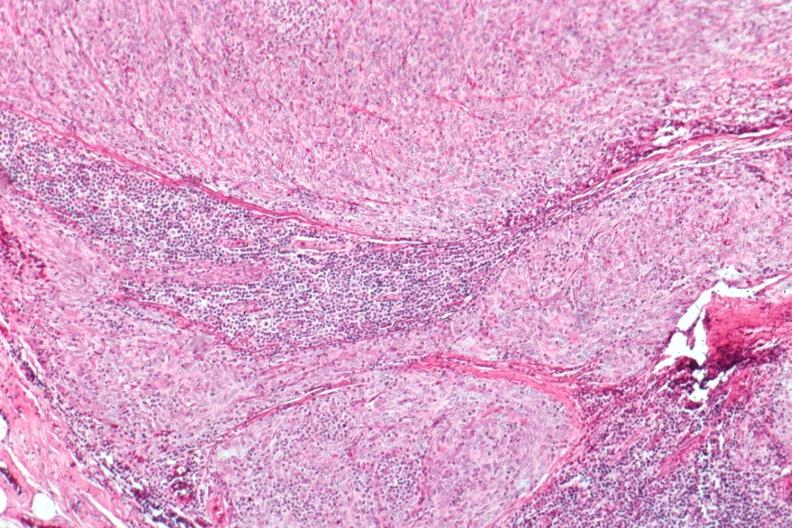s erythrophagocytosis new born present?
Answer the question using a single word or phrase. No 